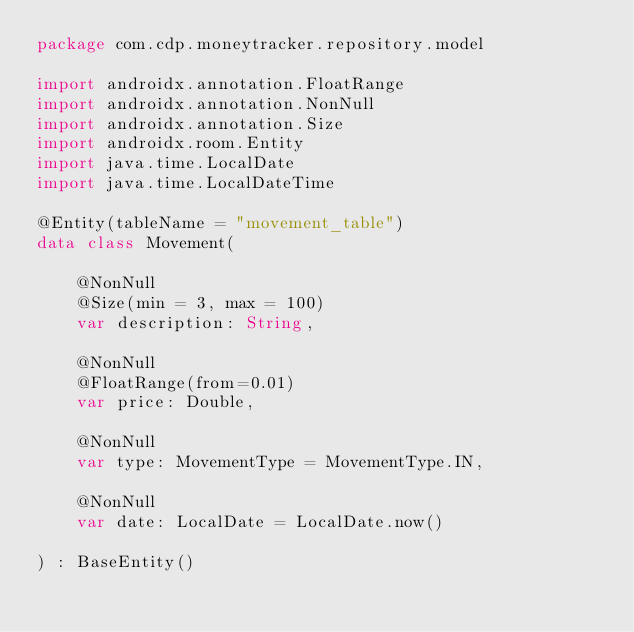<code> <loc_0><loc_0><loc_500><loc_500><_Kotlin_>package com.cdp.moneytracker.repository.model

import androidx.annotation.FloatRange
import androidx.annotation.NonNull
import androidx.annotation.Size
import androidx.room.Entity
import java.time.LocalDate
import java.time.LocalDateTime

@Entity(tableName = "movement_table")
data class Movement(

    @NonNull
    @Size(min = 3, max = 100)
    var description: String,

    @NonNull
    @FloatRange(from=0.01)
    var price: Double,

    @NonNull
    var type: MovementType = MovementType.IN,

    @NonNull
    var date: LocalDate = LocalDate.now()

) : BaseEntity()</code> 